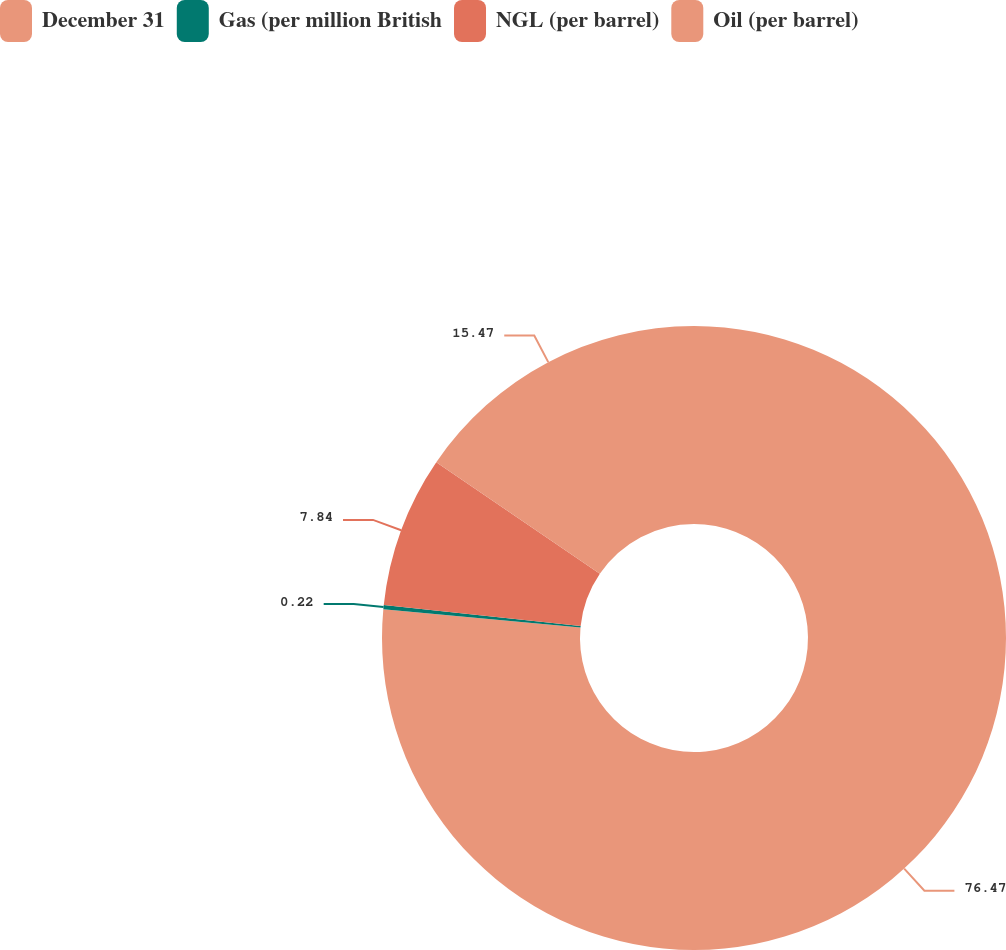<chart> <loc_0><loc_0><loc_500><loc_500><pie_chart><fcel>December 31<fcel>Gas (per million British<fcel>NGL (per barrel)<fcel>Oil (per barrel)<nl><fcel>76.47%<fcel>0.22%<fcel>7.84%<fcel>15.47%<nl></chart> 